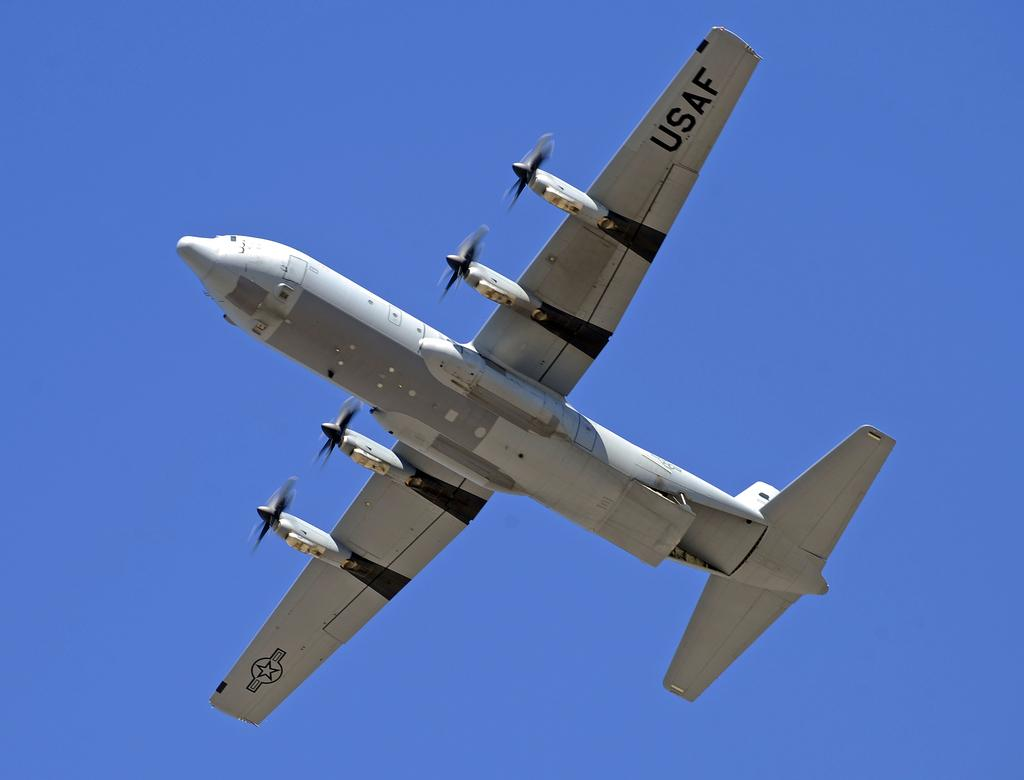What is the main subject of the image? The main subject of the image is an aircraft. Where is the aircraft located in the image? The aircraft is in the center of the image. What type of tank can be seen in the image? There is no tank present in the image; it features an aircraft. How many pies are visible in the image? There are no pies visible in the image. 